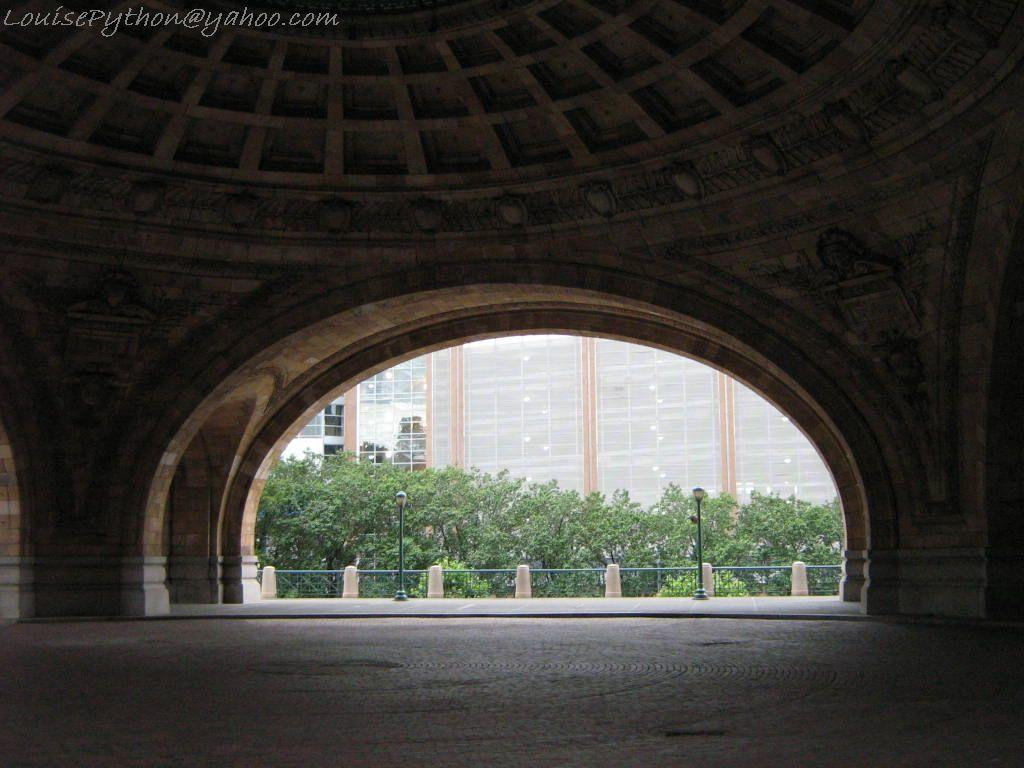What can be seen at the bottom of the image? The ground is visible in the image. What color is the ceiling in the image? The ceiling is brown in color. What vertical structures are present in the image? There are poles in the image. What safety feature can be seen in the image? The railing is present in the image. What type of vegetation is visible in the image? There are green trees in the image. What large structure is visible in the background of the image? There is a huge building in the background of the image. What type of business is being conducted in the image? There is no indication of any business activity in the image. Can you see the brain of any person in the image? There is no brain visible in the image. 